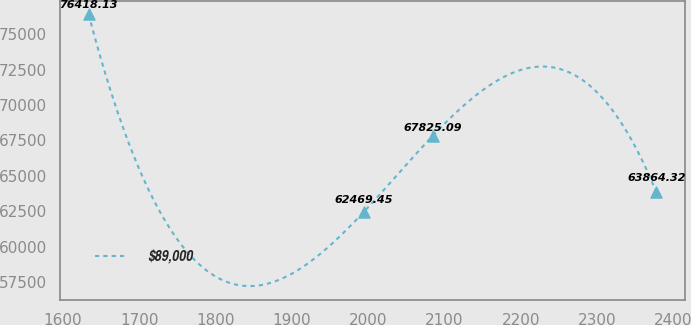<chart> <loc_0><loc_0><loc_500><loc_500><line_chart><ecel><fcel>$89,000<nl><fcel>1633.97<fcel>76418.1<nl><fcel>1994.69<fcel>62469.4<nl><fcel>2084.54<fcel>67825.1<nl><fcel>2377.4<fcel>63864.3<nl></chart> 